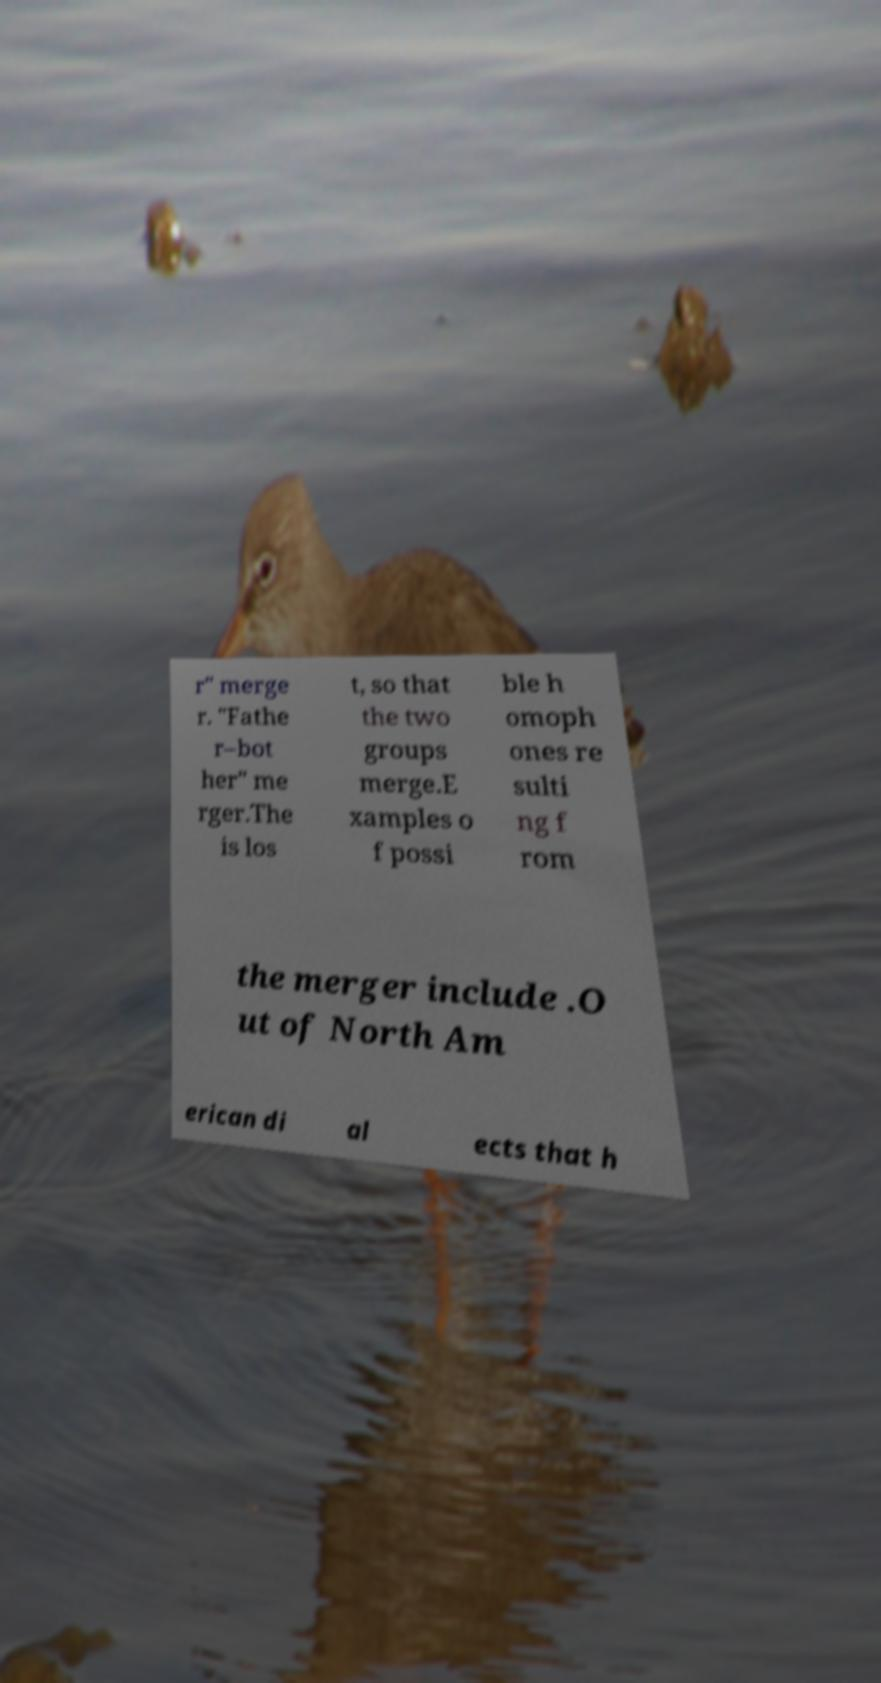There's text embedded in this image that I need extracted. Can you transcribe it verbatim? r" merge r. "Fathe r–bot her" me rger.The is los t, so that the two groups merge.E xamples o f possi ble h omoph ones re sulti ng f rom the merger include .O ut of North Am erican di al ects that h 